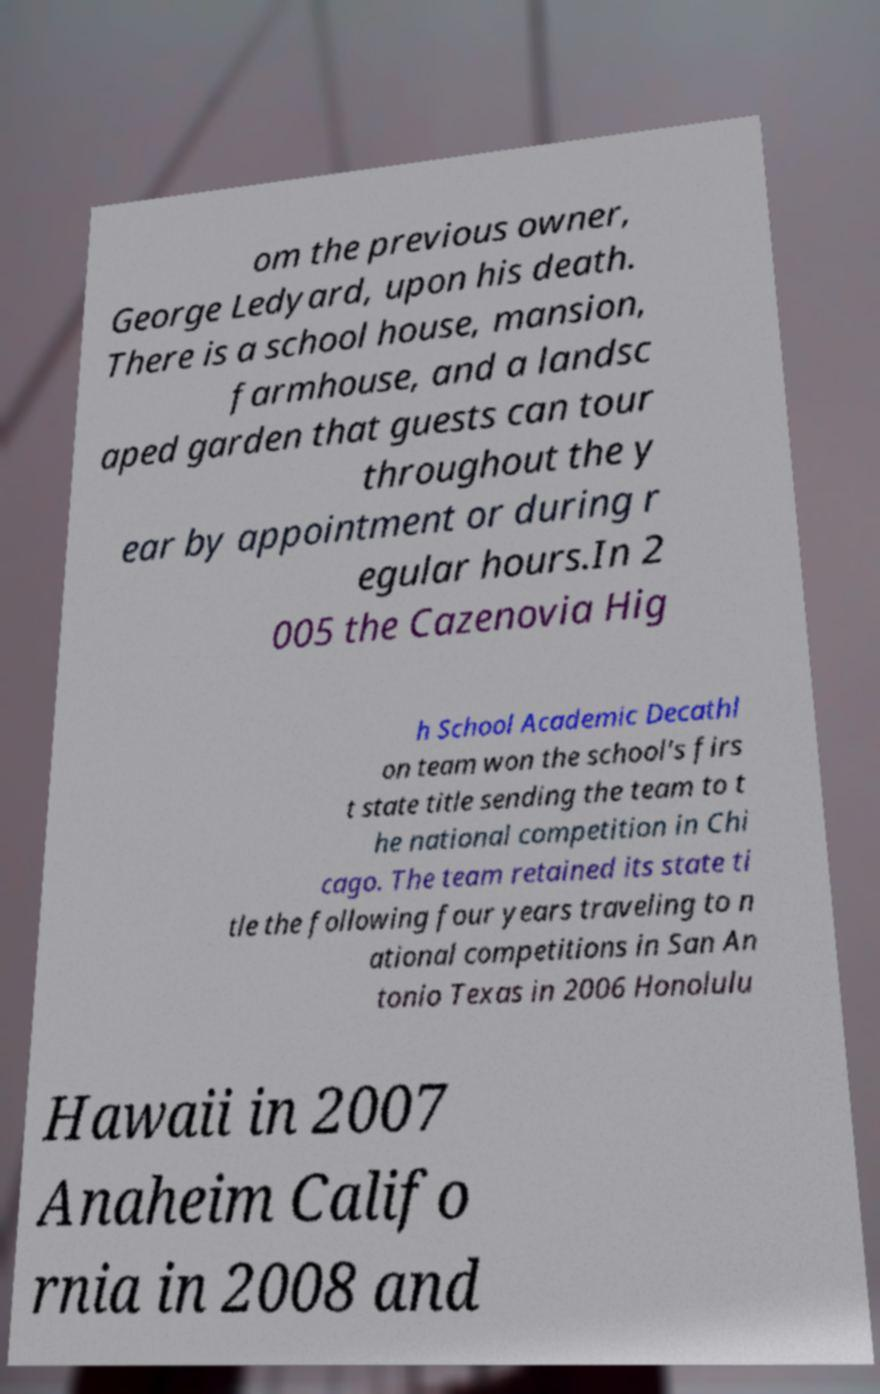Please read and relay the text visible in this image. What does it say? om the previous owner, George Ledyard, upon his death. There is a school house, mansion, farmhouse, and a landsc aped garden that guests can tour throughout the y ear by appointment or during r egular hours.In 2 005 the Cazenovia Hig h School Academic Decathl on team won the school's firs t state title sending the team to t he national competition in Chi cago. The team retained its state ti tle the following four years traveling to n ational competitions in San An tonio Texas in 2006 Honolulu Hawaii in 2007 Anaheim Califo rnia in 2008 and 